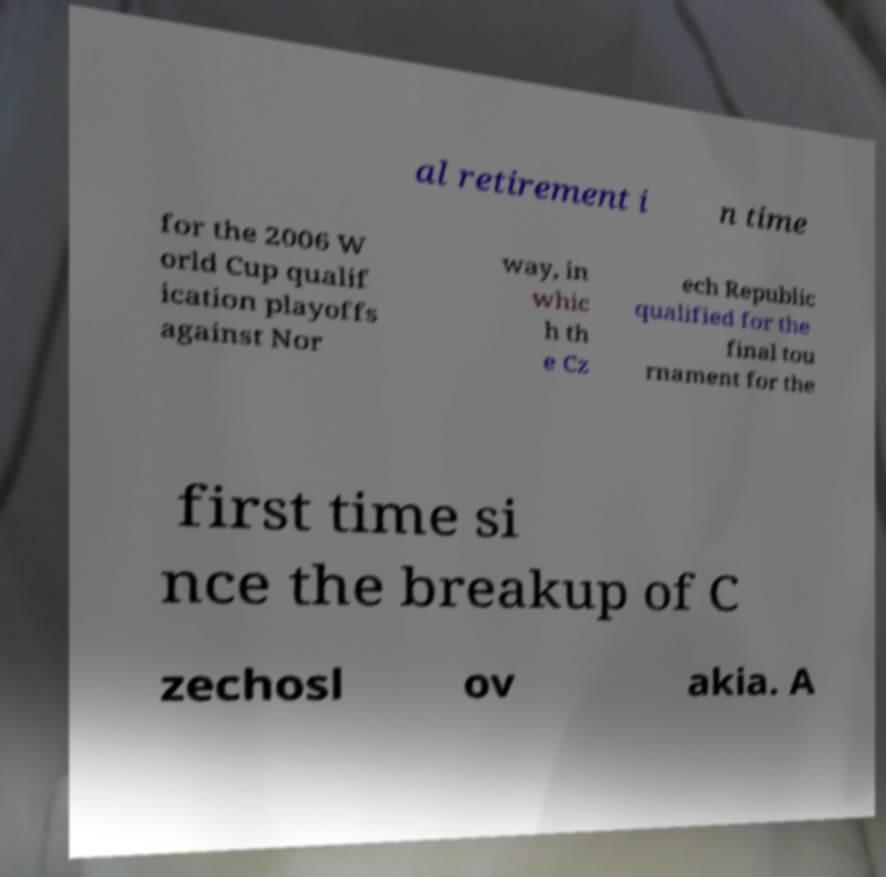Please read and relay the text visible in this image. What does it say? al retirement i n time for the 2006 W orld Cup qualif ication playoffs against Nor way, in whic h th e Cz ech Republic qualified for the final tou rnament for the first time si nce the breakup of C zechosl ov akia. A 